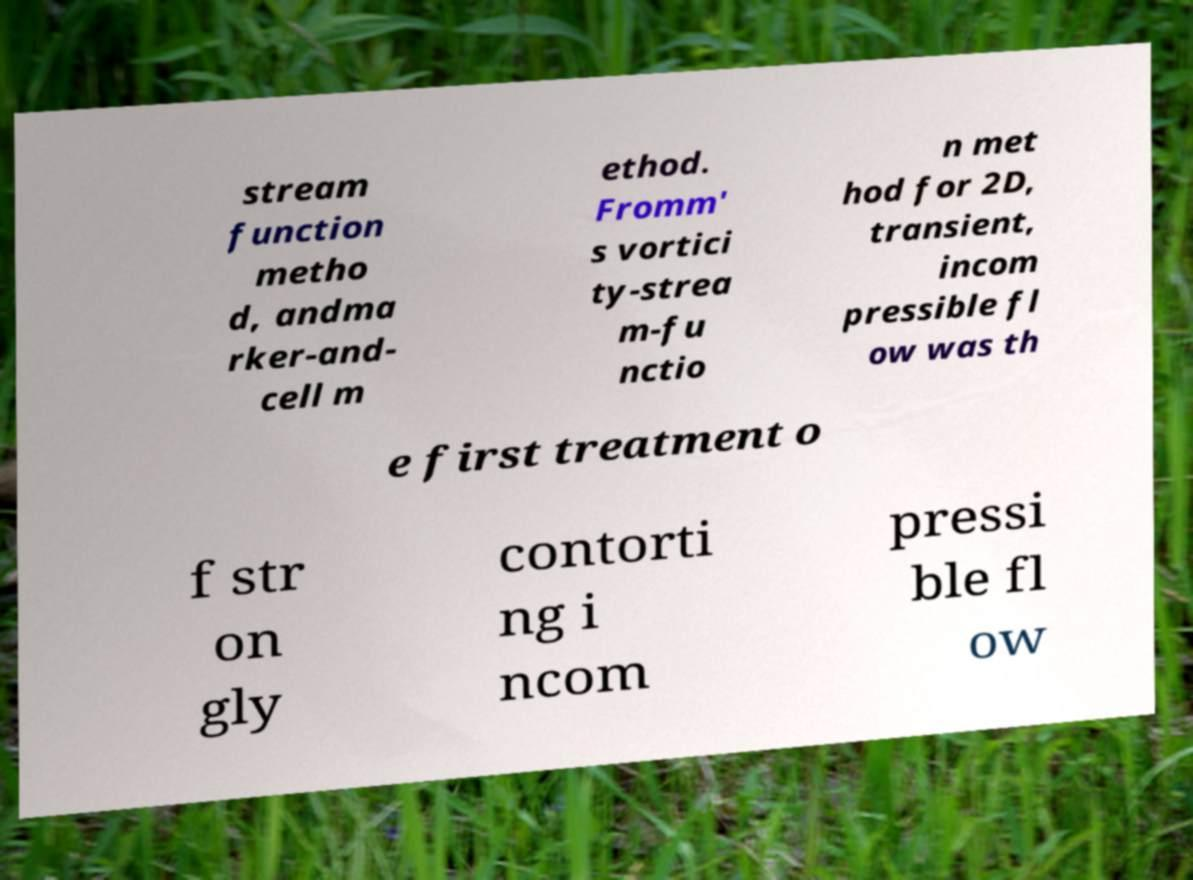Please identify and transcribe the text found in this image. stream function metho d, andma rker-and- cell m ethod. Fromm' s vortici ty-strea m-fu nctio n met hod for 2D, transient, incom pressible fl ow was th e first treatment o f str on gly contorti ng i ncom pressi ble fl ow 